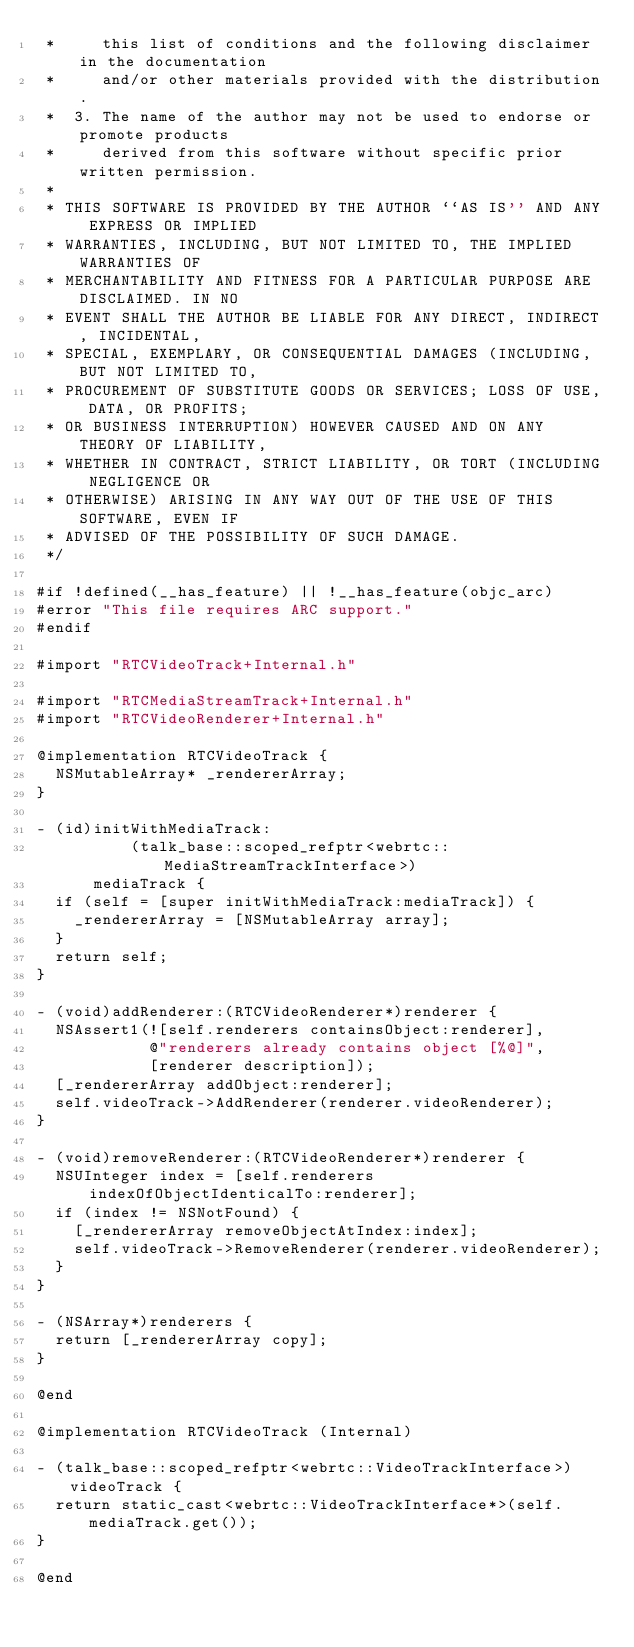Convert code to text. <code><loc_0><loc_0><loc_500><loc_500><_ObjectiveC_> *     this list of conditions and the following disclaimer in the documentation
 *     and/or other materials provided with the distribution.
 *  3. The name of the author may not be used to endorse or promote products
 *     derived from this software without specific prior written permission.
 *
 * THIS SOFTWARE IS PROVIDED BY THE AUTHOR ``AS IS'' AND ANY EXPRESS OR IMPLIED
 * WARRANTIES, INCLUDING, BUT NOT LIMITED TO, THE IMPLIED WARRANTIES OF
 * MERCHANTABILITY AND FITNESS FOR A PARTICULAR PURPOSE ARE DISCLAIMED. IN NO
 * EVENT SHALL THE AUTHOR BE LIABLE FOR ANY DIRECT, INDIRECT, INCIDENTAL,
 * SPECIAL, EXEMPLARY, OR CONSEQUENTIAL DAMAGES (INCLUDING, BUT NOT LIMITED TO,
 * PROCUREMENT OF SUBSTITUTE GOODS OR SERVICES; LOSS OF USE, DATA, OR PROFITS;
 * OR BUSINESS INTERRUPTION) HOWEVER CAUSED AND ON ANY THEORY OF LIABILITY,
 * WHETHER IN CONTRACT, STRICT LIABILITY, OR TORT (INCLUDING NEGLIGENCE OR
 * OTHERWISE) ARISING IN ANY WAY OUT OF THE USE OF THIS SOFTWARE, EVEN IF
 * ADVISED OF THE POSSIBILITY OF SUCH DAMAGE.
 */

#if !defined(__has_feature) || !__has_feature(objc_arc)
#error "This file requires ARC support."
#endif

#import "RTCVideoTrack+Internal.h"

#import "RTCMediaStreamTrack+Internal.h"
#import "RTCVideoRenderer+Internal.h"

@implementation RTCVideoTrack {
  NSMutableArray* _rendererArray;
}

- (id)initWithMediaTrack:
          (talk_base::scoped_refptr<webrtc::MediaStreamTrackInterface>)
      mediaTrack {
  if (self = [super initWithMediaTrack:mediaTrack]) {
    _rendererArray = [NSMutableArray array];
  }
  return self;
}

- (void)addRenderer:(RTCVideoRenderer*)renderer {
  NSAssert1(![self.renderers containsObject:renderer],
            @"renderers already contains object [%@]",
            [renderer description]);
  [_rendererArray addObject:renderer];
  self.videoTrack->AddRenderer(renderer.videoRenderer);
}

- (void)removeRenderer:(RTCVideoRenderer*)renderer {
  NSUInteger index = [self.renderers indexOfObjectIdenticalTo:renderer];
  if (index != NSNotFound) {
    [_rendererArray removeObjectAtIndex:index];
    self.videoTrack->RemoveRenderer(renderer.videoRenderer);
  }
}

- (NSArray*)renderers {
  return [_rendererArray copy];
}

@end

@implementation RTCVideoTrack (Internal)

- (talk_base::scoped_refptr<webrtc::VideoTrackInterface>)videoTrack {
  return static_cast<webrtc::VideoTrackInterface*>(self.mediaTrack.get());
}

@end
</code> 